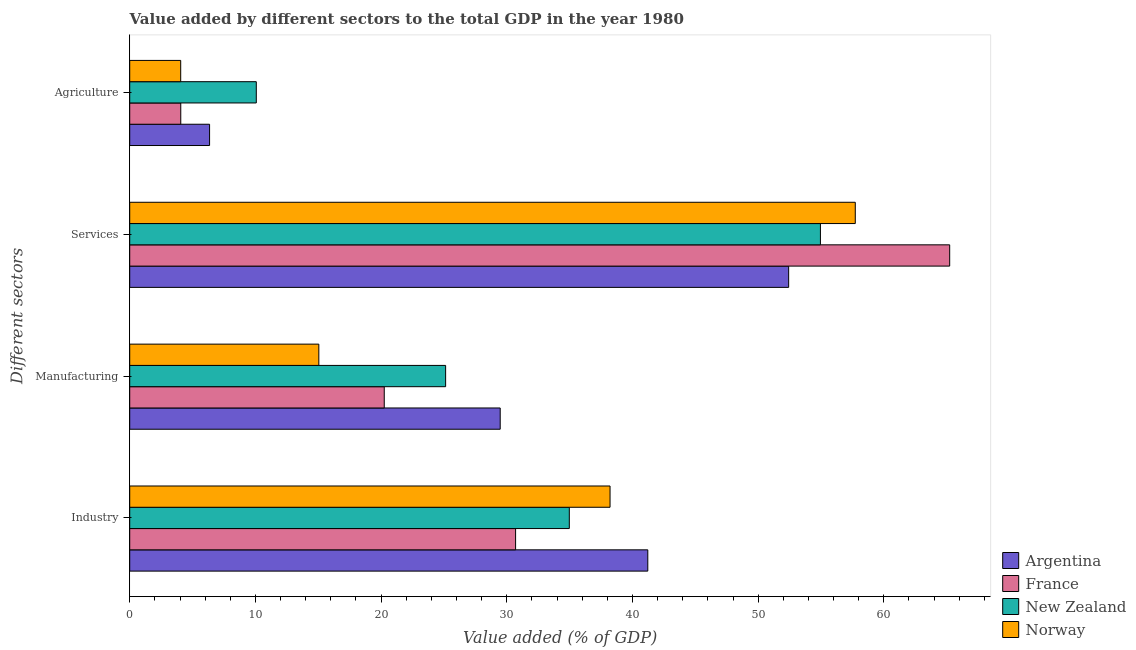How many different coloured bars are there?
Your answer should be compact. 4. How many groups of bars are there?
Offer a very short reply. 4. How many bars are there on the 3rd tick from the top?
Your answer should be compact. 4. What is the label of the 2nd group of bars from the top?
Keep it short and to the point. Services. What is the value added by agricultural sector in New Zealand?
Ensure brevity in your answer.  10.07. Across all countries, what is the maximum value added by services sector?
Offer a terse response. 65.24. Across all countries, what is the minimum value added by industrial sector?
Ensure brevity in your answer.  30.7. In which country was the value added by manufacturing sector maximum?
Provide a succinct answer. Argentina. What is the total value added by agricultural sector in the graph?
Your answer should be compact. 24.54. What is the difference between the value added by services sector in France and that in New Zealand?
Offer a very short reply. 10.28. What is the difference between the value added by agricultural sector in New Zealand and the value added by manufacturing sector in France?
Your answer should be very brief. -10.18. What is the average value added by manufacturing sector per country?
Your answer should be compact. 22.48. What is the difference between the value added by industrial sector and value added by services sector in France?
Provide a short and direct response. -34.54. In how many countries, is the value added by services sector greater than 2 %?
Offer a terse response. 4. What is the ratio of the value added by industrial sector in Norway to that in Argentina?
Your answer should be compact. 0.93. What is the difference between the highest and the second highest value added by industrial sector?
Offer a very short reply. 3. What is the difference between the highest and the lowest value added by services sector?
Give a very brief answer. 12.81. Is it the case that in every country, the sum of the value added by industrial sector and value added by manufacturing sector is greater than the sum of value added by agricultural sector and value added by services sector?
Your answer should be very brief. No. What does the 2nd bar from the top in Agriculture represents?
Ensure brevity in your answer.  New Zealand. What does the 3rd bar from the bottom in Industry represents?
Offer a very short reply. New Zealand. How many bars are there?
Provide a short and direct response. 16. How many countries are there in the graph?
Give a very brief answer. 4. Are the values on the major ticks of X-axis written in scientific E-notation?
Your answer should be very brief. No. What is the title of the graph?
Keep it short and to the point. Value added by different sectors to the total GDP in the year 1980. What is the label or title of the X-axis?
Keep it short and to the point. Value added (% of GDP). What is the label or title of the Y-axis?
Provide a short and direct response. Different sectors. What is the Value added (% of GDP) of Argentina in Industry?
Make the answer very short. 41.22. What is the Value added (% of GDP) in France in Industry?
Make the answer very short. 30.7. What is the Value added (% of GDP) of New Zealand in Industry?
Keep it short and to the point. 34.98. What is the Value added (% of GDP) of Norway in Industry?
Your answer should be very brief. 38.22. What is the Value added (% of GDP) of Argentina in Manufacturing?
Provide a short and direct response. 29.48. What is the Value added (% of GDP) of France in Manufacturing?
Your answer should be very brief. 20.25. What is the Value added (% of GDP) of New Zealand in Manufacturing?
Offer a terse response. 25.13. What is the Value added (% of GDP) of Norway in Manufacturing?
Ensure brevity in your answer.  15.05. What is the Value added (% of GDP) in Argentina in Services?
Your answer should be very brief. 52.43. What is the Value added (% of GDP) of France in Services?
Provide a succinct answer. 65.24. What is the Value added (% of GDP) of New Zealand in Services?
Provide a short and direct response. 54.95. What is the Value added (% of GDP) in Norway in Services?
Provide a succinct answer. 57.73. What is the Value added (% of GDP) in Argentina in Agriculture?
Offer a very short reply. 6.35. What is the Value added (% of GDP) of France in Agriculture?
Make the answer very short. 4.06. What is the Value added (% of GDP) of New Zealand in Agriculture?
Ensure brevity in your answer.  10.07. What is the Value added (% of GDP) in Norway in Agriculture?
Provide a succinct answer. 4.06. Across all Different sectors, what is the maximum Value added (% of GDP) of Argentina?
Provide a succinct answer. 52.43. Across all Different sectors, what is the maximum Value added (% of GDP) in France?
Ensure brevity in your answer.  65.24. Across all Different sectors, what is the maximum Value added (% of GDP) in New Zealand?
Make the answer very short. 54.95. Across all Different sectors, what is the maximum Value added (% of GDP) in Norway?
Your answer should be very brief. 57.73. Across all Different sectors, what is the minimum Value added (% of GDP) of Argentina?
Offer a very short reply. 6.35. Across all Different sectors, what is the minimum Value added (% of GDP) in France?
Provide a short and direct response. 4.06. Across all Different sectors, what is the minimum Value added (% of GDP) of New Zealand?
Provide a succinct answer. 10.07. Across all Different sectors, what is the minimum Value added (% of GDP) of Norway?
Ensure brevity in your answer.  4.06. What is the total Value added (% of GDP) of Argentina in the graph?
Make the answer very short. 129.48. What is the total Value added (% of GDP) of France in the graph?
Offer a terse response. 120.25. What is the total Value added (% of GDP) in New Zealand in the graph?
Make the answer very short. 125.13. What is the total Value added (% of GDP) in Norway in the graph?
Ensure brevity in your answer.  115.05. What is the difference between the Value added (% of GDP) in Argentina in Industry and that in Manufacturing?
Provide a succinct answer. 11.74. What is the difference between the Value added (% of GDP) of France in Industry and that in Manufacturing?
Offer a terse response. 10.45. What is the difference between the Value added (% of GDP) of New Zealand in Industry and that in Manufacturing?
Your response must be concise. 9.84. What is the difference between the Value added (% of GDP) of Norway in Industry and that in Manufacturing?
Offer a terse response. 23.17. What is the difference between the Value added (% of GDP) of Argentina in Industry and that in Services?
Offer a very short reply. -11.21. What is the difference between the Value added (% of GDP) in France in Industry and that in Services?
Offer a very short reply. -34.54. What is the difference between the Value added (% of GDP) of New Zealand in Industry and that in Services?
Offer a terse response. -19.98. What is the difference between the Value added (% of GDP) of Norway in Industry and that in Services?
Your response must be concise. -19.51. What is the difference between the Value added (% of GDP) in Argentina in Industry and that in Agriculture?
Your response must be concise. 34.87. What is the difference between the Value added (% of GDP) of France in Industry and that in Agriculture?
Provide a short and direct response. 26.64. What is the difference between the Value added (% of GDP) of New Zealand in Industry and that in Agriculture?
Keep it short and to the point. 24.9. What is the difference between the Value added (% of GDP) of Norway in Industry and that in Agriculture?
Ensure brevity in your answer.  34.16. What is the difference between the Value added (% of GDP) of Argentina in Manufacturing and that in Services?
Make the answer very short. -22.95. What is the difference between the Value added (% of GDP) of France in Manufacturing and that in Services?
Your answer should be compact. -44.99. What is the difference between the Value added (% of GDP) of New Zealand in Manufacturing and that in Services?
Keep it short and to the point. -29.82. What is the difference between the Value added (% of GDP) of Norway in Manufacturing and that in Services?
Provide a succinct answer. -42.68. What is the difference between the Value added (% of GDP) of Argentina in Manufacturing and that in Agriculture?
Make the answer very short. 23.12. What is the difference between the Value added (% of GDP) of France in Manufacturing and that in Agriculture?
Give a very brief answer. 16.19. What is the difference between the Value added (% of GDP) in New Zealand in Manufacturing and that in Agriculture?
Provide a succinct answer. 15.06. What is the difference between the Value added (% of GDP) in Norway in Manufacturing and that in Agriculture?
Your response must be concise. 10.99. What is the difference between the Value added (% of GDP) in Argentina in Services and that in Agriculture?
Give a very brief answer. 46.07. What is the difference between the Value added (% of GDP) of France in Services and that in Agriculture?
Your answer should be very brief. 61.18. What is the difference between the Value added (% of GDP) in New Zealand in Services and that in Agriculture?
Offer a very short reply. 44.88. What is the difference between the Value added (% of GDP) of Norway in Services and that in Agriculture?
Offer a terse response. 53.67. What is the difference between the Value added (% of GDP) of Argentina in Industry and the Value added (% of GDP) of France in Manufacturing?
Provide a succinct answer. 20.97. What is the difference between the Value added (% of GDP) of Argentina in Industry and the Value added (% of GDP) of New Zealand in Manufacturing?
Give a very brief answer. 16.09. What is the difference between the Value added (% of GDP) in Argentina in Industry and the Value added (% of GDP) in Norway in Manufacturing?
Ensure brevity in your answer.  26.17. What is the difference between the Value added (% of GDP) of France in Industry and the Value added (% of GDP) of New Zealand in Manufacturing?
Offer a terse response. 5.57. What is the difference between the Value added (% of GDP) in France in Industry and the Value added (% of GDP) in Norway in Manufacturing?
Offer a very short reply. 15.65. What is the difference between the Value added (% of GDP) of New Zealand in Industry and the Value added (% of GDP) of Norway in Manufacturing?
Your answer should be compact. 19.93. What is the difference between the Value added (% of GDP) of Argentina in Industry and the Value added (% of GDP) of France in Services?
Ensure brevity in your answer.  -24.02. What is the difference between the Value added (% of GDP) of Argentina in Industry and the Value added (% of GDP) of New Zealand in Services?
Keep it short and to the point. -13.73. What is the difference between the Value added (% of GDP) of Argentina in Industry and the Value added (% of GDP) of Norway in Services?
Provide a short and direct response. -16.51. What is the difference between the Value added (% of GDP) in France in Industry and the Value added (% of GDP) in New Zealand in Services?
Your answer should be very brief. -24.25. What is the difference between the Value added (% of GDP) in France in Industry and the Value added (% of GDP) in Norway in Services?
Keep it short and to the point. -27.03. What is the difference between the Value added (% of GDP) of New Zealand in Industry and the Value added (% of GDP) of Norway in Services?
Offer a very short reply. -22.75. What is the difference between the Value added (% of GDP) of Argentina in Industry and the Value added (% of GDP) of France in Agriculture?
Offer a terse response. 37.16. What is the difference between the Value added (% of GDP) in Argentina in Industry and the Value added (% of GDP) in New Zealand in Agriculture?
Offer a terse response. 31.15. What is the difference between the Value added (% of GDP) in Argentina in Industry and the Value added (% of GDP) in Norway in Agriculture?
Provide a short and direct response. 37.16. What is the difference between the Value added (% of GDP) of France in Industry and the Value added (% of GDP) of New Zealand in Agriculture?
Provide a succinct answer. 20.63. What is the difference between the Value added (% of GDP) in France in Industry and the Value added (% of GDP) in Norway in Agriculture?
Your answer should be compact. 26.64. What is the difference between the Value added (% of GDP) in New Zealand in Industry and the Value added (% of GDP) in Norway in Agriculture?
Ensure brevity in your answer.  30.92. What is the difference between the Value added (% of GDP) in Argentina in Manufacturing and the Value added (% of GDP) in France in Services?
Your answer should be compact. -35.76. What is the difference between the Value added (% of GDP) in Argentina in Manufacturing and the Value added (% of GDP) in New Zealand in Services?
Provide a succinct answer. -25.48. What is the difference between the Value added (% of GDP) in Argentina in Manufacturing and the Value added (% of GDP) in Norway in Services?
Offer a very short reply. -28.25. What is the difference between the Value added (% of GDP) of France in Manufacturing and the Value added (% of GDP) of New Zealand in Services?
Offer a very short reply. -34.7. What is the difference between the Value added (% of GDP) in France in Manufacturing and the Value added (% of GDP) in Norway in Services?
Your answer should be compact. -37.48. What is the difference between the Value added (% of GDP) in New Zealand in Manufacturing and the Value added (% of GDP) in Norway in Services?
Provide a short and direct response. -32.59. What is the difference between the Value added (% of GDP) of Argentina in Manufacturing and the Value added (% of GDP) of France in Agriculture?
Your answer should be compact. 25.42. What is the difference between the Value added (% of GDP) in Argentina in Manufacturing and the Value added (% of GDP) in New Zealand in Agriculture?
Give a very brief answer. 19.41. What is the difference between the Value added (% of GDP) in Argentina in Manufacturing and the Value added (% of GDP) in Norway in Agriculture?
Your response must be concise. 25.42. What is the difference between the Value added (% of GDP) in France in Manufacturing and the Value added (% of GDP) in New Zealand in Agriculture?
Your answer should be compact. 10.18. What is the difference between the Value added (% of GDP) in France in Manufacturing and the Value added (% of GDP) in Norway in Agriculture?
Provide a succinct answer. 16.2. What is the difference between the Value added (% of GDP) in New Zealand in Manufacturing and the Value added (% of GDP) in Norway in Agriculture?
Your response must be concise. 21.08. What is the difference between the Value added (% of GDP) of Argentina in Services and the Value added (% of GDP) of France in Agriculture?
Keep it short and to the point. 48.37. What is the difference between the Value added (% of GDP) in Argentina in Services and the Value added (% of GDP) in New Zealand in Agriculture?
Offer a terse response. 42.36. What is the difference between the Value added (% of GDP) in Argentina in Services and the Value added (% of GDP) in Norway in Agriculture?
Make the answer very short. 48.37. What is the difference between the Value added (% of GDP) in France in Services and the Value added (% of GDP) in New Zealand in Agriculture?
Make the answer very short. 55.17. What is the difference between the Value added (% of GDP) of France in Services and the Value added (% of GDP) of Norway in Agriculture?
Ensure brevity in your answer.  61.18. What is the difference between the Value added (% of GDP) of New Zealand in Services and the Value added (% of GDP) of Norway in Agriculture?
Your response must be concise. 50.9. What is the average Value added (% of GDP) of Argentina per Different sectors?
Give a very brief answer. 32.37. What is the average Value added (% of GDP) of France per Different sectors?
Offer a very short reply. 30.06. What is the average Value added (% of GDP) in New Zealand per Different sectors?
Offer a terse response. 31.28. What is the average Value added (% of GDP) in Norway per Different sectors?
Keep it short and to the point. 28.76. What is the difference between the Value added (% of GDP) in Argentina and Value added (% of GDP) in France in Industry?
Ensure brevity in your answer.  10.52. What is the difference between the Value added (% of GDP) of Argentina and Value added (% of GDP) of New Zealand in Industry?
Ensure brevity in your answer.  6.24. What is the difference between the Value added (% of GDP) in Argentina and Value added (% of GDP) in Norway in Industry?
Provide a succinct answer. 3. What is the difference between the Value added (% of GDP) in France and Value added (% of GDP) in New Zealand in Industry?
Provide a short and direct response. -4.27. What is the difference between the Value added (% of GDP) of France and Value added (% of GDP) of Norway in Industry?
Keep it short and to the point. -7.52. What is the difference between the Value added (% of GDP) of New Zealand and Value added (% of GDP) of Norway in Industry?
Offer a terse response. -3.24. What is the difference between the Value added (% of GDP) of Argentina and Value added (% of GDP) of France in Manufacturing?
Give a very brief answer. 9.22. What is the difference between the Value added (% of GDP) in Argentina and Value added (% of GDP) in New Zealand in Manufacturing?
Offer a very short reply. 4.34. What is the difference between the Value added (% of GDP) in Argentina and Value added (% of GDP) in Norway in Manufacturing?
Keep it short and to the point. 14.43. What is the difference between the Value added (% of GDP) in France and Value added (% of GDP) in New Zealand in Manufacturing?
Offer a terse response. -4.88. What is the difference between the Value added (% of GDP) in France and Value added (% of GDP) in Norway in Manufacturing?
Give a very brief answer. 5.21. What is the difference between the Value added (% of GDP) in New Zealand and Value added (% of GDP) in Norway in Manufacturing?
Offer a terse response. 10.09. What is the difference between the Value added (% of GDP) of Argentina and Value added (% of GDP) of France in Services?
Your answer should be compact. -12.81. What is the difference between the Value added (% of GDP) of Argentina and Value added (% of GDP) of New Zealand in Services?
Your response must be concise. -2.53. What is the difference between the Value added (% of GDP) of Argentina and Value added (% of GDP) of Norway in Services?
Give a very brief answer. -5.3. What is the difference between the Value added (% of GDP) of France and Value added (% of GDP) of New Zealand in Services?
Make the answer very short. 10.28. What is the difference between the Value added (% of GDP) in France and Value added (% of GDP) in Norway in Services?
Make the answer very short. 7.51. What is the difference between the Value added (% of GDP) in New Zealand and Value added (% of GDP) in Norway in Services?
Your answer should be compact. -2.77. What is the difference between the Value added (% of GDP) in Argentina and Value added (% of GDP) in France in Agriculture?
Keep it short and to the point. 2.29. What is the difference between the Value added (% of GDP) in Argentina and Value added (% of GDP) in New Zealand in Agriculture?
Provide a succinct answer. -3.72. What is the difference between the Value added (% of GDP) in Argentina and Value added (% of GDP) in Norway in Agriculture?
Ensure brevity in your answer.  2.3. What is the difference between the Value added (% of GDP) in France and Value added (% of GDP) in New Zealand in Agriculture?
Ensure brevity in your answer.  -6.01. What is the difference between the Value added (% of GDP) in France and Value added (% of GDP) in Norway in Agriculture?
Offer a very short reply. 0.01. What is the difference between the Value added (% of GDP) in New Zealand and Value added (% of GDP) in Norway in Agriculture?
Ensure brevity in your answer.  6.02. What is the ratio of the Value added (% of GDP) in Argentina in Industry to that in Manufacturing?
Give a very brief answer. 1.4. What is the ratio of the Value added (% of GDP) in France in Industry to that in Manufacturing?
Ensure brevity in your answer.  1.52. What is the ratio of the Value added (% of GDP) of New Zealand in Industry to that in Manufacturing?
Your answer should be very brief. 1.39. What is the ratio of the Value added (% of GDP) in Norway in Industry to that in Manufacturing?
Make the answer very short. 2.54. What is the ratio of the Value added (% of GDP) of Argentina in Industry to that in Services?
Your answer should be very brief. 0.79. What is the ratio of the Value added (% of GDP) in France in Industry to that in Services?
Provide a short and direct response. 0.47. What is the ratio of the Value added (% of GDP) of New Zealand in Industry to that in Services?
Your response must be concise. 0.64. What is the ratio of the Value added (% of GDP) in Norway in Industry to that in Services?
Your response must be concise. 0.66. What is the ratio of the Value added (% of GDP) of Argentina in Industry to that in Agriculture?
Make the answer very short. 6.49. What is the ratio of the Value added (% of GDP) in France in Industry to that in Agriculture?
Keep it short and to the point. 7.56. What is the ratio of the Value added (% of GDP) in New Zealand in Industry to that in Agriculture?
Your answer should be very brief. 3.47. What is the ratio of the Value added (% of GDP) in Norway in Industry to that in Agriculture?
Your response must be concise. 9.42. What is the ratio of the Value added (% of GDP) in Argentina in Manufacturing to that in Services?
Make the answer very short. 0.56. What is the ratio of the Value added (% of GDP) in France in Manufacturing to that in Services?
Your answer should be compact. 0.31. What is the ratio of the Value added (% of GDP) of New Zealand in Manufacturing to that in Services?
Offer a very short reply. 0.46. What is the ratio of the Value added (% of GDP) in Norway in Manufacturing to that in Services?
Your answer should be compact. 0.26. What is the ratio of the Value added (% of GDP) of Argentina in Manufacturing to that in Agriculture?
Your response must be concise. 4.64. What is the ratio of the Value added (% of GDP) in France in Manufacturing to that in Agriculture?
Provide a succinct answer. 4.99. What is the ratio of the Value added (% of GDP) in New Zealand in Manufacturing to that in Agriculture?
Keep it short and to the point. 2.5. What is the ratio of the Value added (% of GDP) in Norway in Manufacturing to that in Agriculture?
Keep it short and to the point. 3.71. What is the ratio of the Value added (% of GDP) in Argentina in Services to that in Agriculture?
Make the answer very short. 8.25. What is the ratio of the Value added (% of GDP) of France in Services to that in Agriculture?
Give a very brief answer. 16.06. What is the ratio of the Value added (% of GDP) of New Zealand in Services to that in Agriculture?
Give a very brief answer. 5.46. What is the ratio of the Value added (% of GDP) of Norway in Services to that in Agriculture?
Make the answer very short. 14.23. What is the difference between the highest and the second highest Value added (% of GDP) of Argentina?
Make the answer very short. 11.21. What is the difference between the highest and the second highest Value added (% of GDP) in France?
Your response must be concise. 34.54. What is the difference between the highest and the second highest Value added (% of GDP) of New Zealand?
Your answer should be compact. 19.98. What is the difference between the highest and the second highest Value added (% of GDP) in Norway?
Provide a short and direct response. 19.51. What is the difference between the highest and the lowest Value added (% of GDP) in Argentina?
Offer a very short reply. 46.07. What is the difference between the highest and the lowest Value added (% of GDP) of France?
Provide a succinct answer. 61.18. What is the difference between the highest and the lowest Value added (% of GDP) in New Zealand?
Make the answer very short. 44.88. What is the difference between the highest and the lowest Value added (% of GDP) in Norway?
Your answer should be compact. 53.67. 